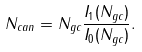Convert formula to latex. <formula><loc_0><loc_0><loc_500><loc_500>N _ { c a n } = N _ { g c } { \frac { I _ { 1 } ( N _ { g c } ) } { I _ { 0 } ( N _ { g c } ) } } .</formula> 